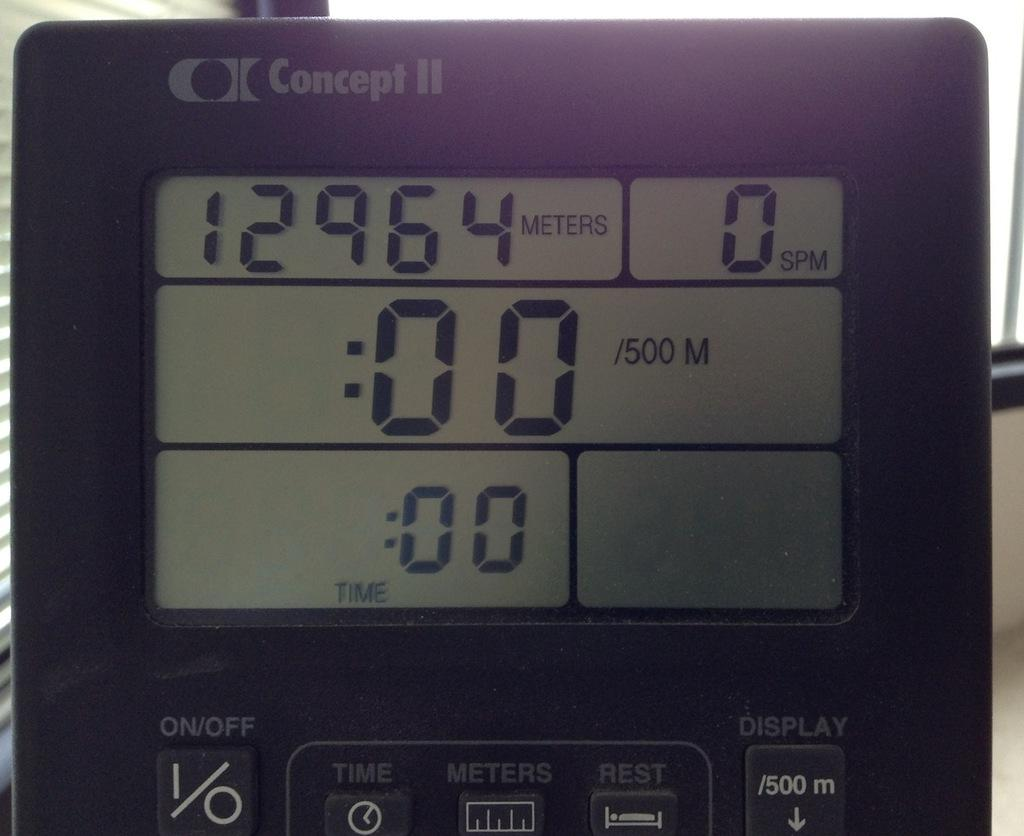<image>
Render a clear and concise summary of the photo. The digital readout on the Concept II gives distance, speed, and time. 